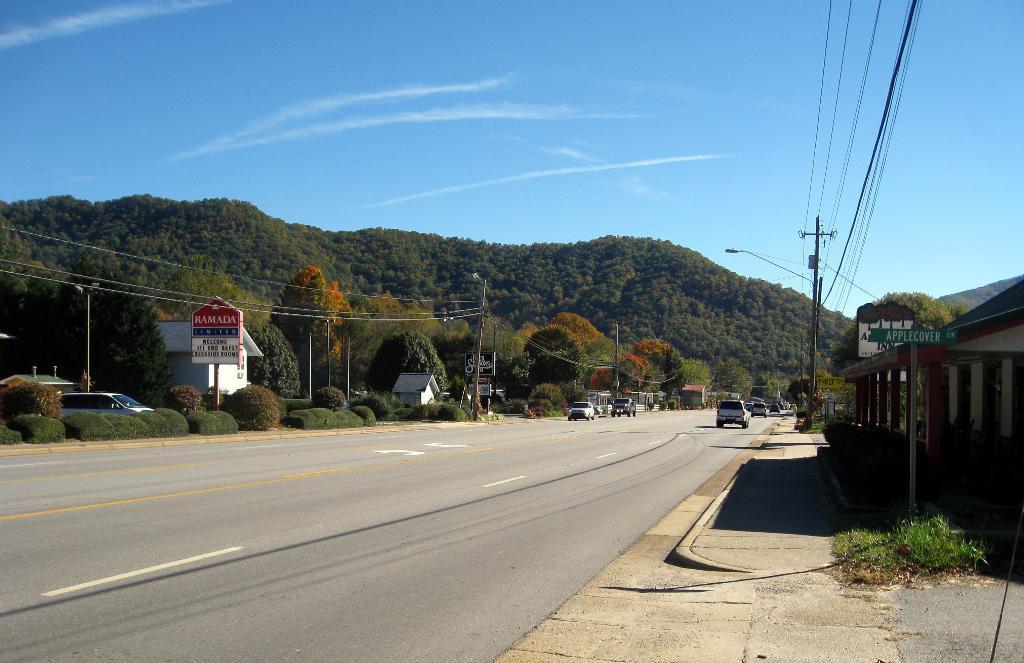Please provide a concise description of this image. In this picture we can see some vehicles on the road, on the right side there is a house, in the background there are some trees, on the left side we can see some plants, poles and boards, on the right side we can see a pole and wires, there is the sky at the top of the picture. 